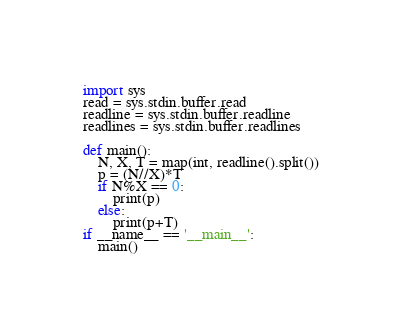<code> <loc_0><loc_0><loc_500><loc_500><_Python_>import sys
read = sys.stdin.buffer.read
readline = sys.stdin.buffer.readline
readlines = sys.stdin.buffer.readlines
 
def main():
    N, X, T = map(int, readline().split())
    p = (N//X)*T
    if N%X == 0:
        print(p)
    else:
        print(p+T)
if __name__ == '__main__':
    main()
</code> 